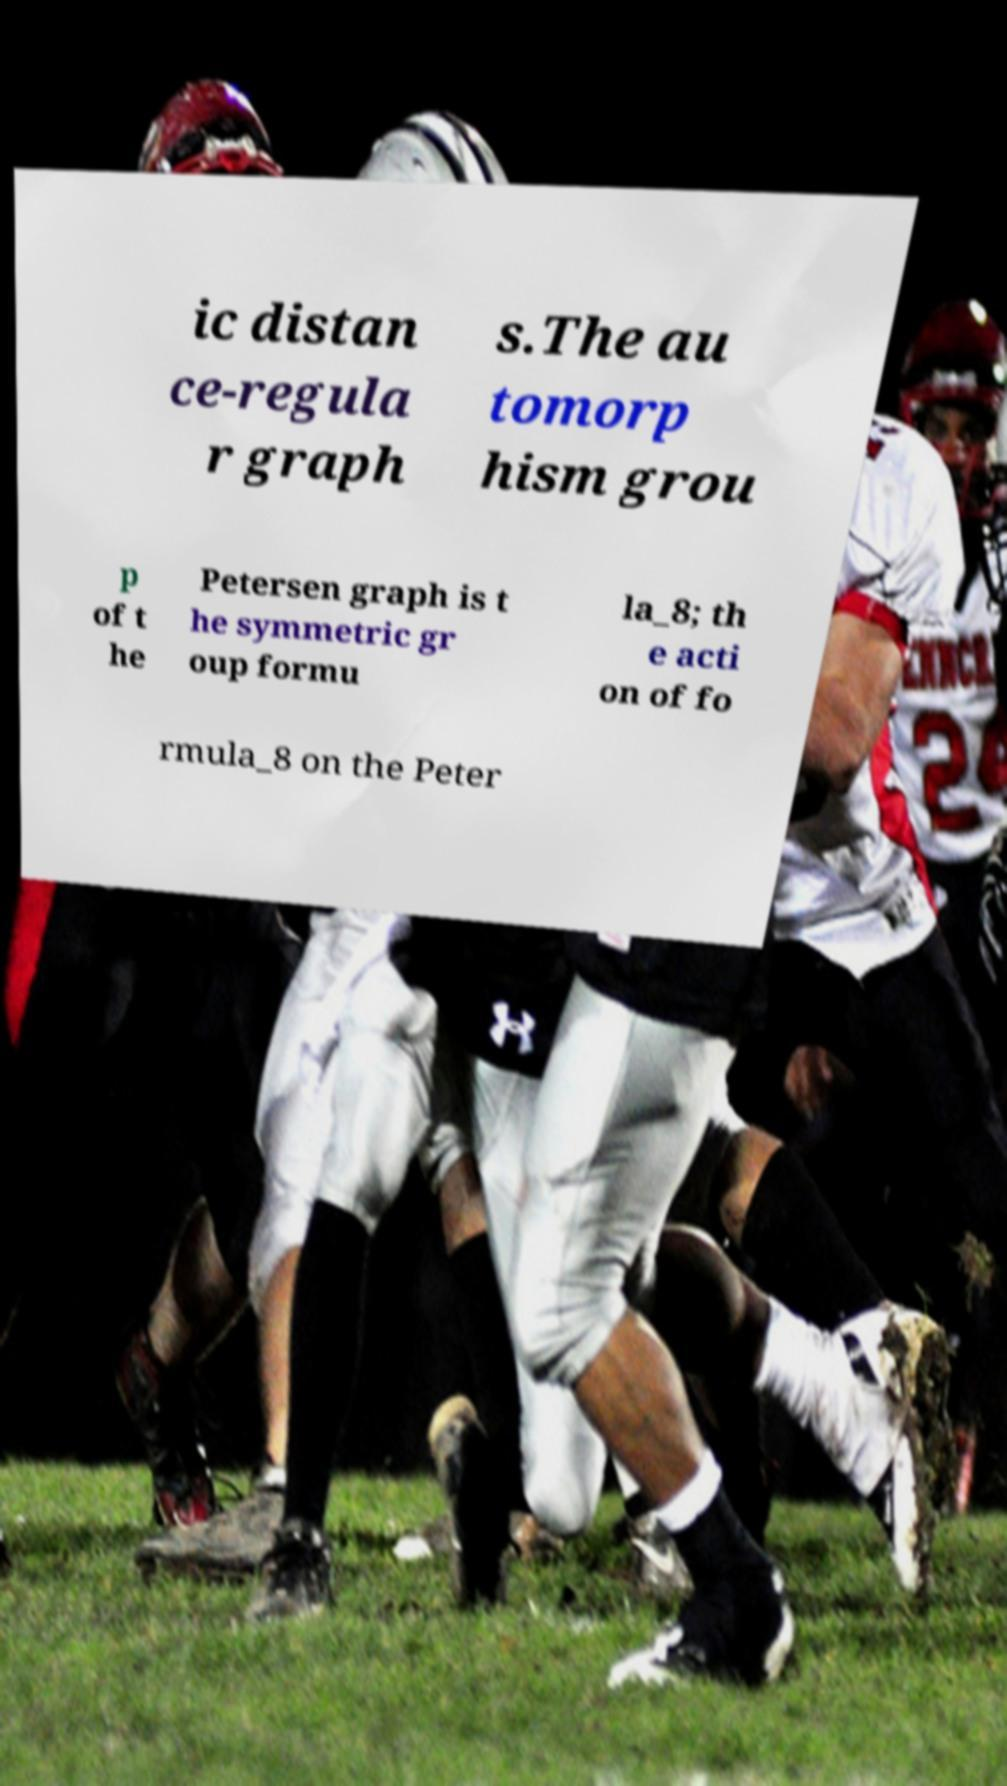For documentation purposes, I need the text within this image transcribed. Could you provide that? ic distan ce-regula r graph s.The au tomorp hism grou p of t he Petersen graph is t he symmetric gr oup formu la_8; th e acti on of fo rmula_8 on the Peter 